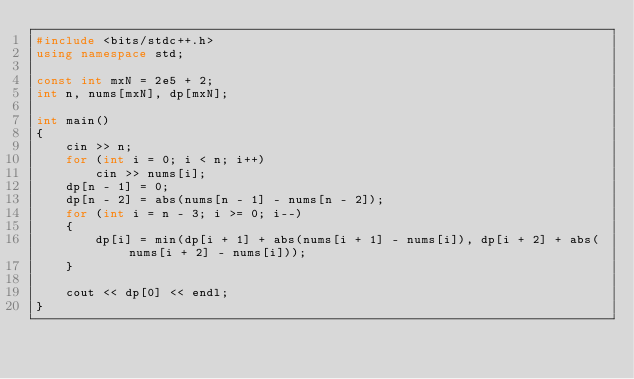<code> <loc_0><loc_0><loc_500><loc_500><_C++_>#include <bits/stdc++.h>
using namespace std;

const int mxN = 2e5 + 2;
int n, nums[mxN], dp[mxN];

int main()
{
    cin >> n;
    for (int i = 0; i < n; i++)
        cin >> nums[i];
    dp[n - 1] = 0;
    dp[n - 2] = abs(nums[n - 1] - nums[n - 2]);
    for (int i = n - 3; i >= 0; i--)
    {
        dp[i] = min(dp[i + 1] + abs(nums[i + 1] - nums[i]), dp[i + 2] + abs(nums[i + 2] - nums[i]));
    }

    cout << dp[0] << endl;
}</code> 